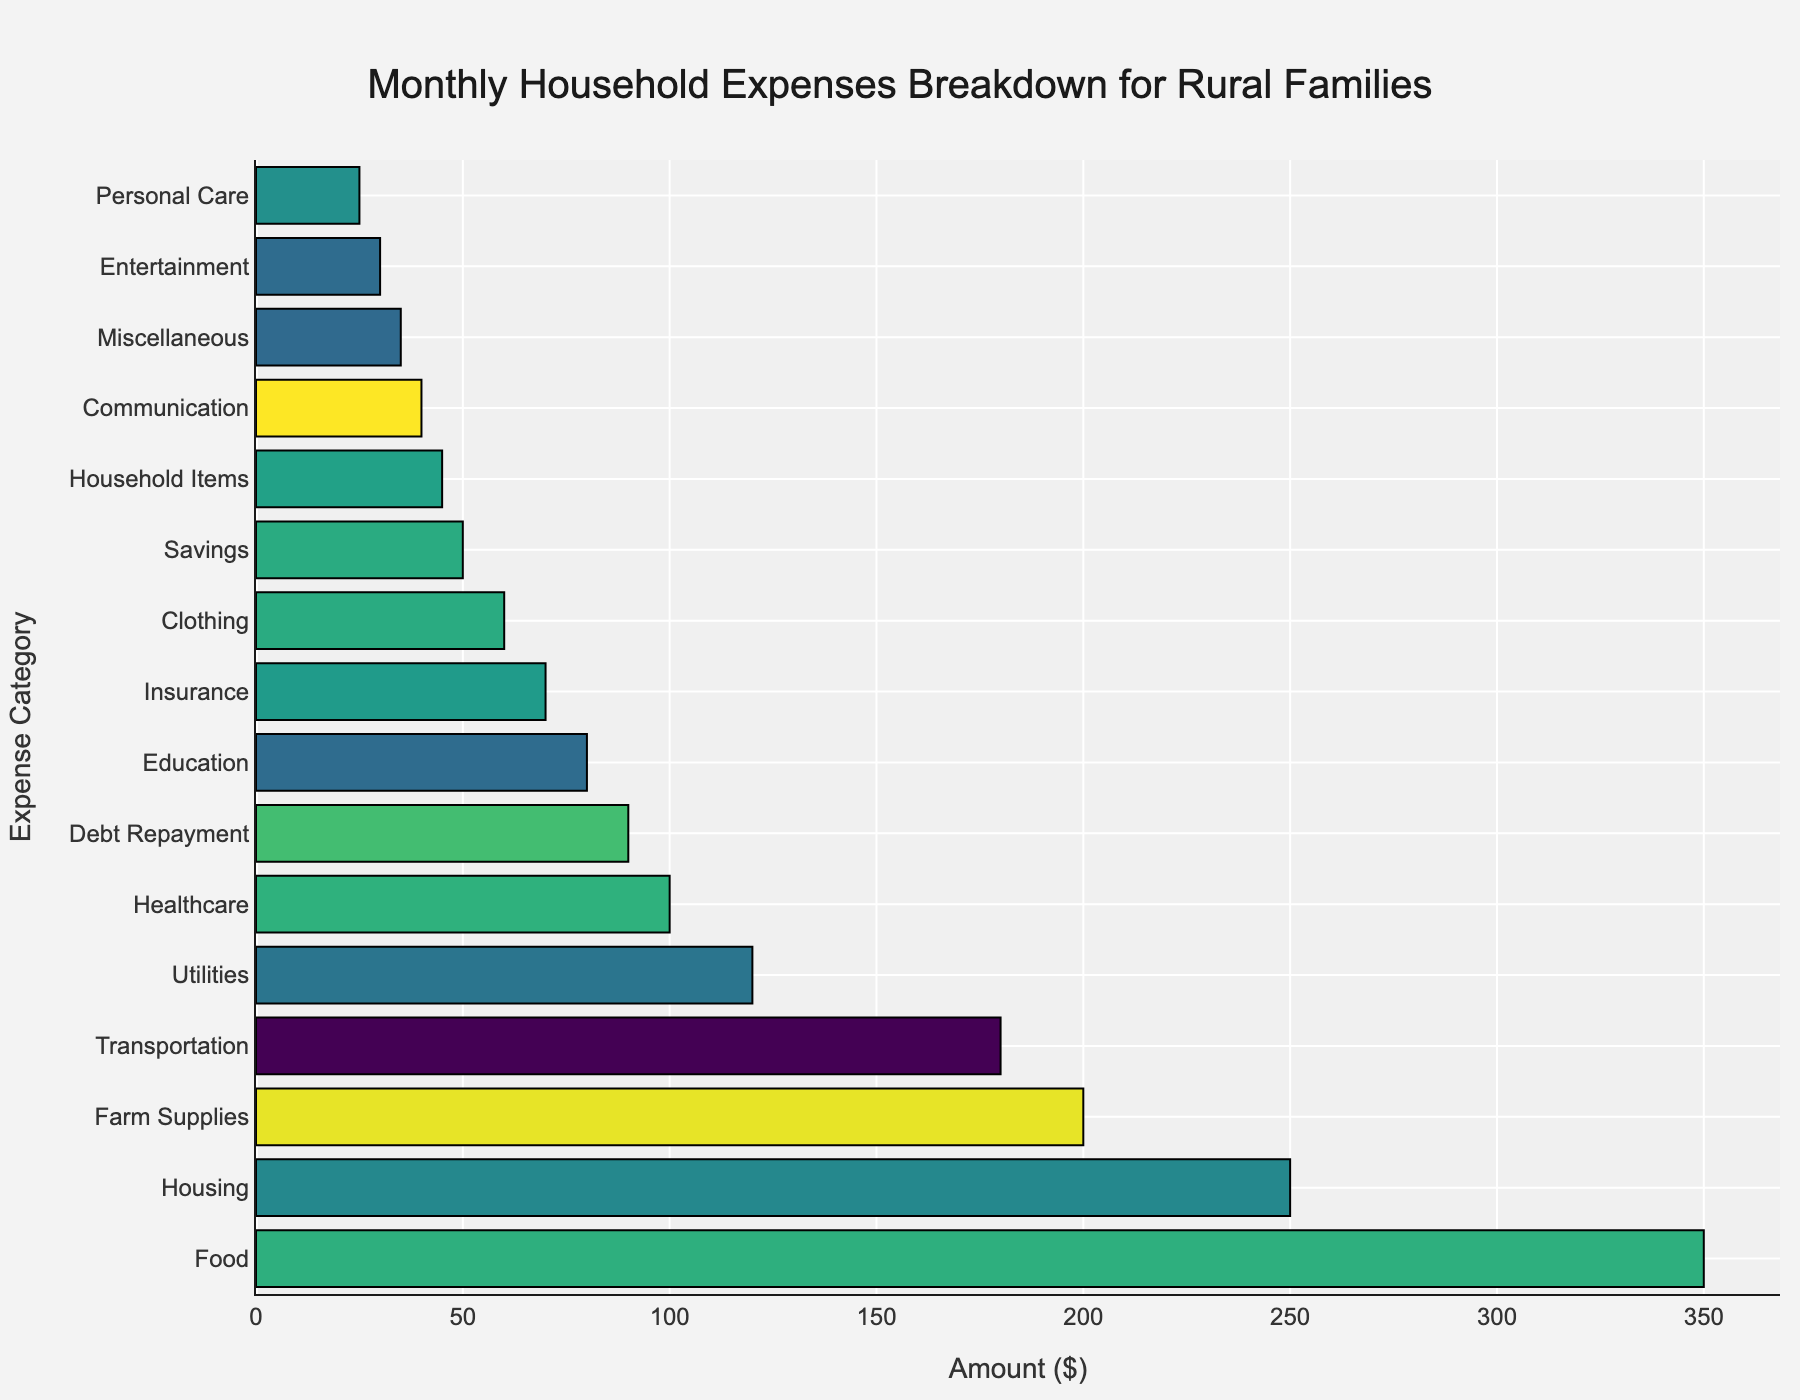Which expense category has the highest amount? The bar chart displays expense categories on the y-axis and their corresponding amounts on the x-axis. The category "Food" is the longest bar, indicating it has the highest amount.
Answer: Food What is the total amount spent on Food and Housing combined? To find the combined amount, add the amount spent on Food (350) and the amount spent on Housing (250).
Answer: 600 Which category has a higher expense, Farm Supplies or Debt Repayment? By comparing the lengths of the bars for "Farm Supplies" and "Debt Repayment," Farm Supplies (200) has a higher expense than Debt Repayment (90).
Answer: Farm Supplies Is the expense on Education greater than the expense on Clothing? The bar for Education (80) is longer than the bar for Clothing (60), indicating that the expense on Education is greater.
Answer: Yes What is the average amount spent on Transportation, Healthcare, and Education? To find the average, sum the amounts spent on Transportation (180), Healthcare (100), and Education (80) and then divide by 3: (180 + 100 + 80) / 3 = 360 / 3.
Answer: 120 Which expense category is the least among all listed? The shortest bar represents the least amount, which is "Personal Care" with an amount of 25.
Answer: Personal Care How much more is spent on Transportation compared to Entertainment? Subtract the amount spent on Entertainment (30) from the amount spent on Transportation (180): 180 - 30 = 150.
Answer: 150 Are the combined expenses on Insurance and Savings greater than those on Healthcare? First, sum the expenses on Insurance (70) and Savings (50): 70 + 50 = 120. Then, compare this sum to Healthcare (100). Since 120 > 100, combined expenses on Insurance and Savings are greater.
Answer: Yes What is the difference between the amounts spent on Utilities and Communication? Subtract the amount spent on Communication (40) from the amount spent on Utilities (120): 120 - 40 = 80.
Answer: 80 Which category has an amount closest to 40 and what is that amount? By visually inspecting the bars, Communication has an amount of 40, which matches exactly.
Answer: Communication 